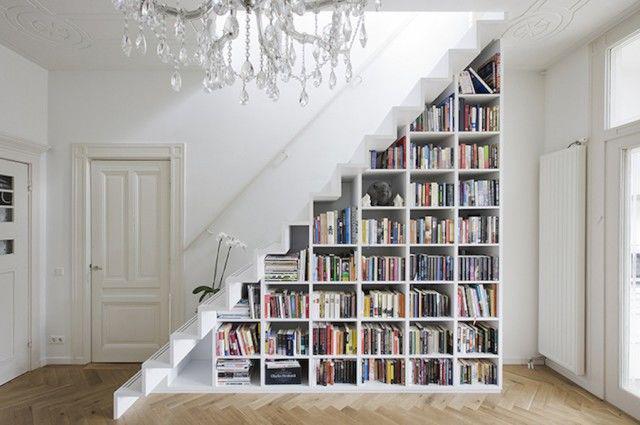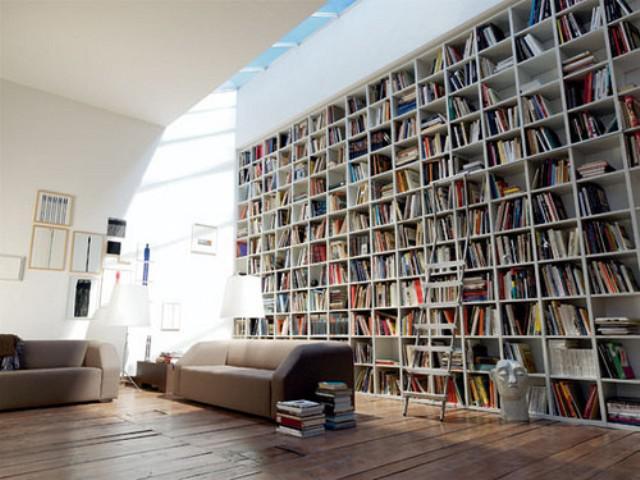The first image is the image on the left, the second image is the image on the right. Assess this claim about the two images: "A room with a bookcase includes a flight of stairs.". Correct or not? Answer yes or no. Yes. 